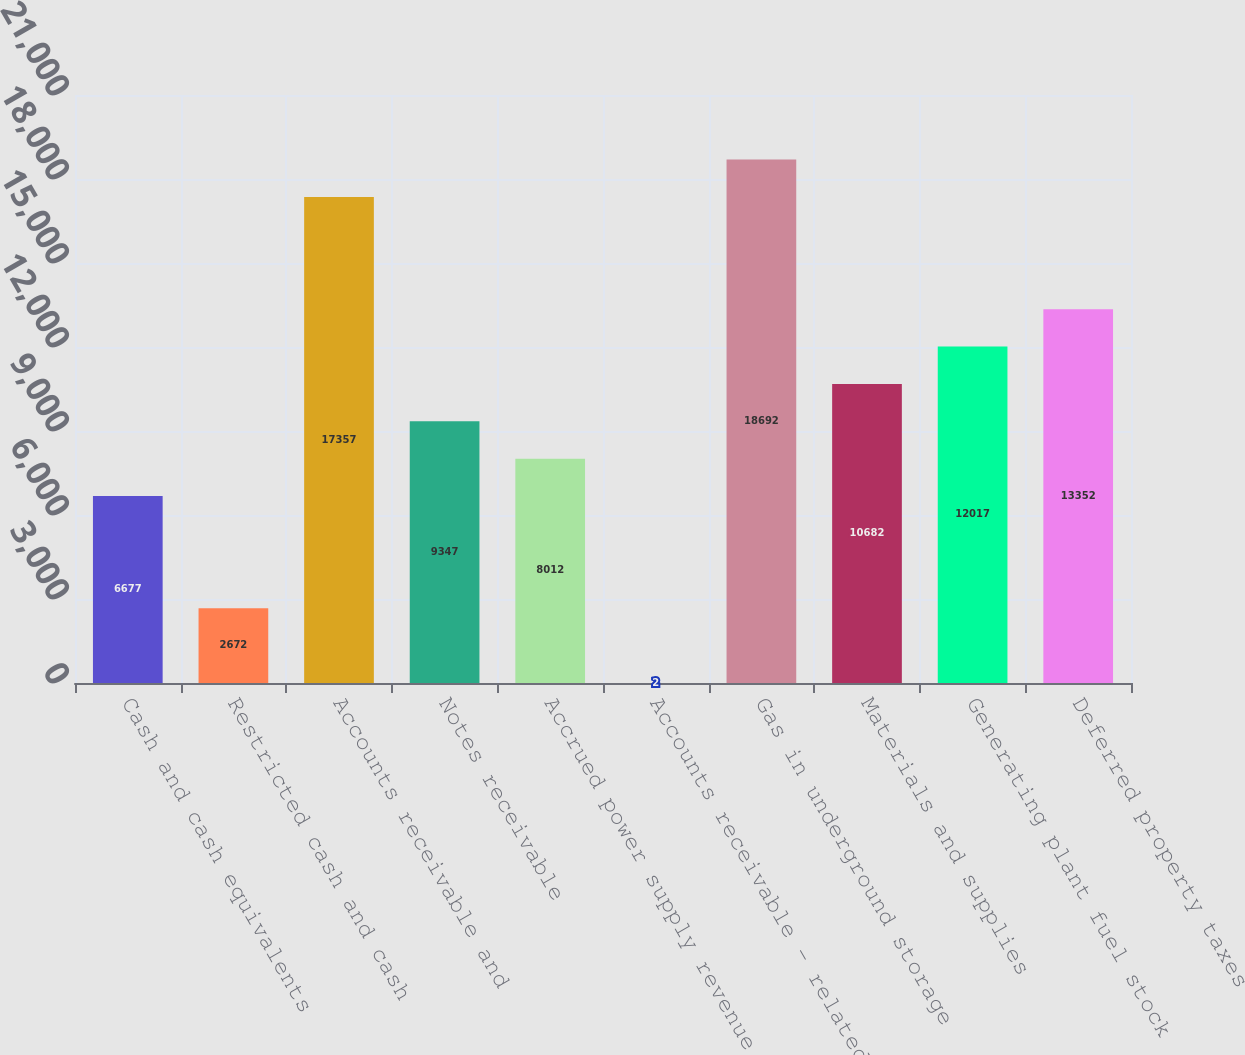Convert chart. <chart><loc_0><loc_0><loc_500><loc_500><bar_chart><fcel>Cash and cash equivalents<fcel>Restricted cash and cash<fcel>Accounts receivable and<fcel>Notes receivable<fcel>Accrued power supply revenue<fcel>Accounts receivable - related<fcel>Gas in underground storage<fcel>Materials and supplies<fcel>Generating plant fuel stock<fcel>Deferred property taxes<nl><fcel>6677<fcel>2672<fcel>17357<fcel>9347<fcel>8012<fcel>2<fcel>18692<fcel>10682<fcel>12017<fcel>13352<nl></chart> 